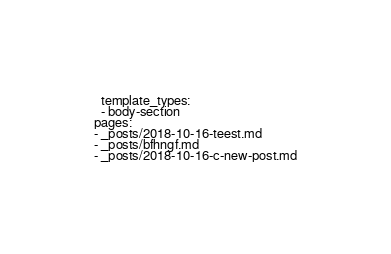<code> <loc_0><loc_0><loc_500><loc_500><_YAML_>  template_types:
  - body-section
pages:
- _posts/2018-10-16-teest.md
- _posts/bfhngf.md
- _posts/2018-10-16-c-new-post.md
</code> 